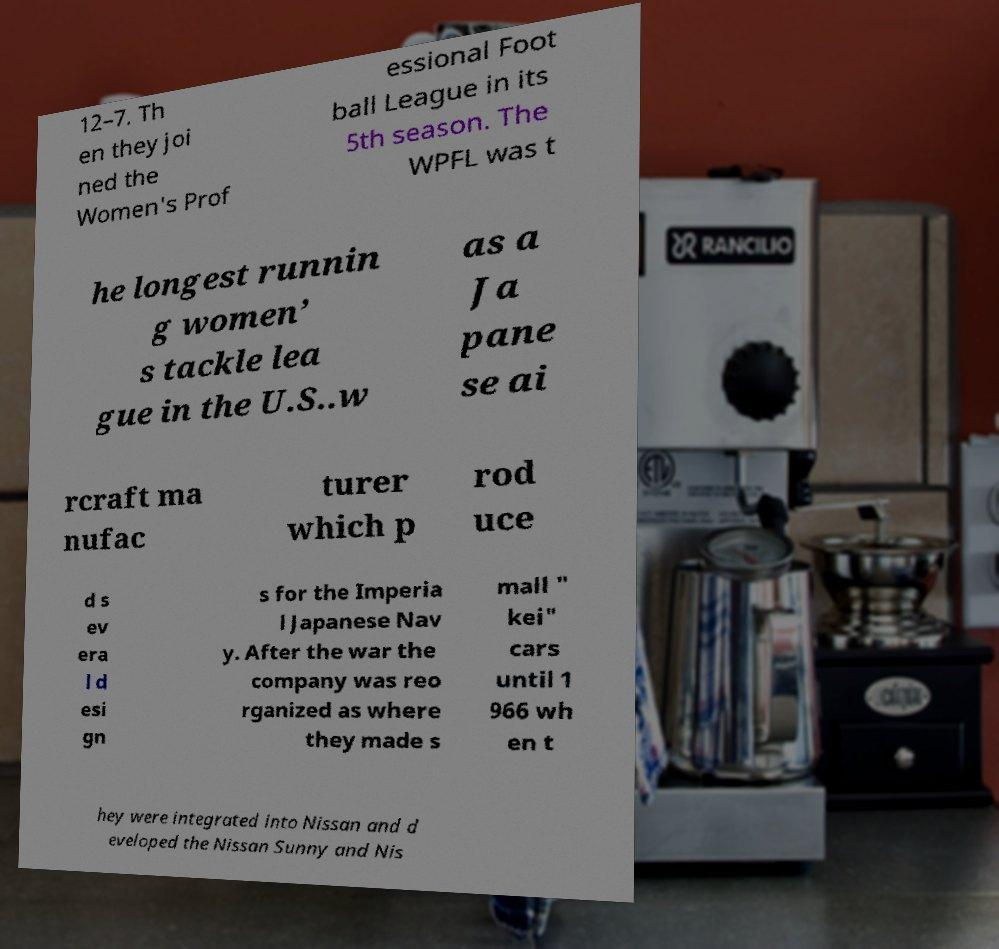There's text embedded in this image that I need extracted. Can you transcribe it verbatim? 12–7. Th en they joi ned the Women's Prof essional Foot ball League in its 5th season. The WPFL was t he longest runnin g women’ s tackle lea gue in the U.S..w as a Ja pane se ai rcraft ma nufac turer which p rod uce d s ev era l d esi gn s for the Imperia l Japanese Nav y. After the war the company was reo rganized as where they made s mall " kei" cars until 1 966 wh en t hey were integrated into Nissan and d eveloped the Nissan Sunny and Nis 